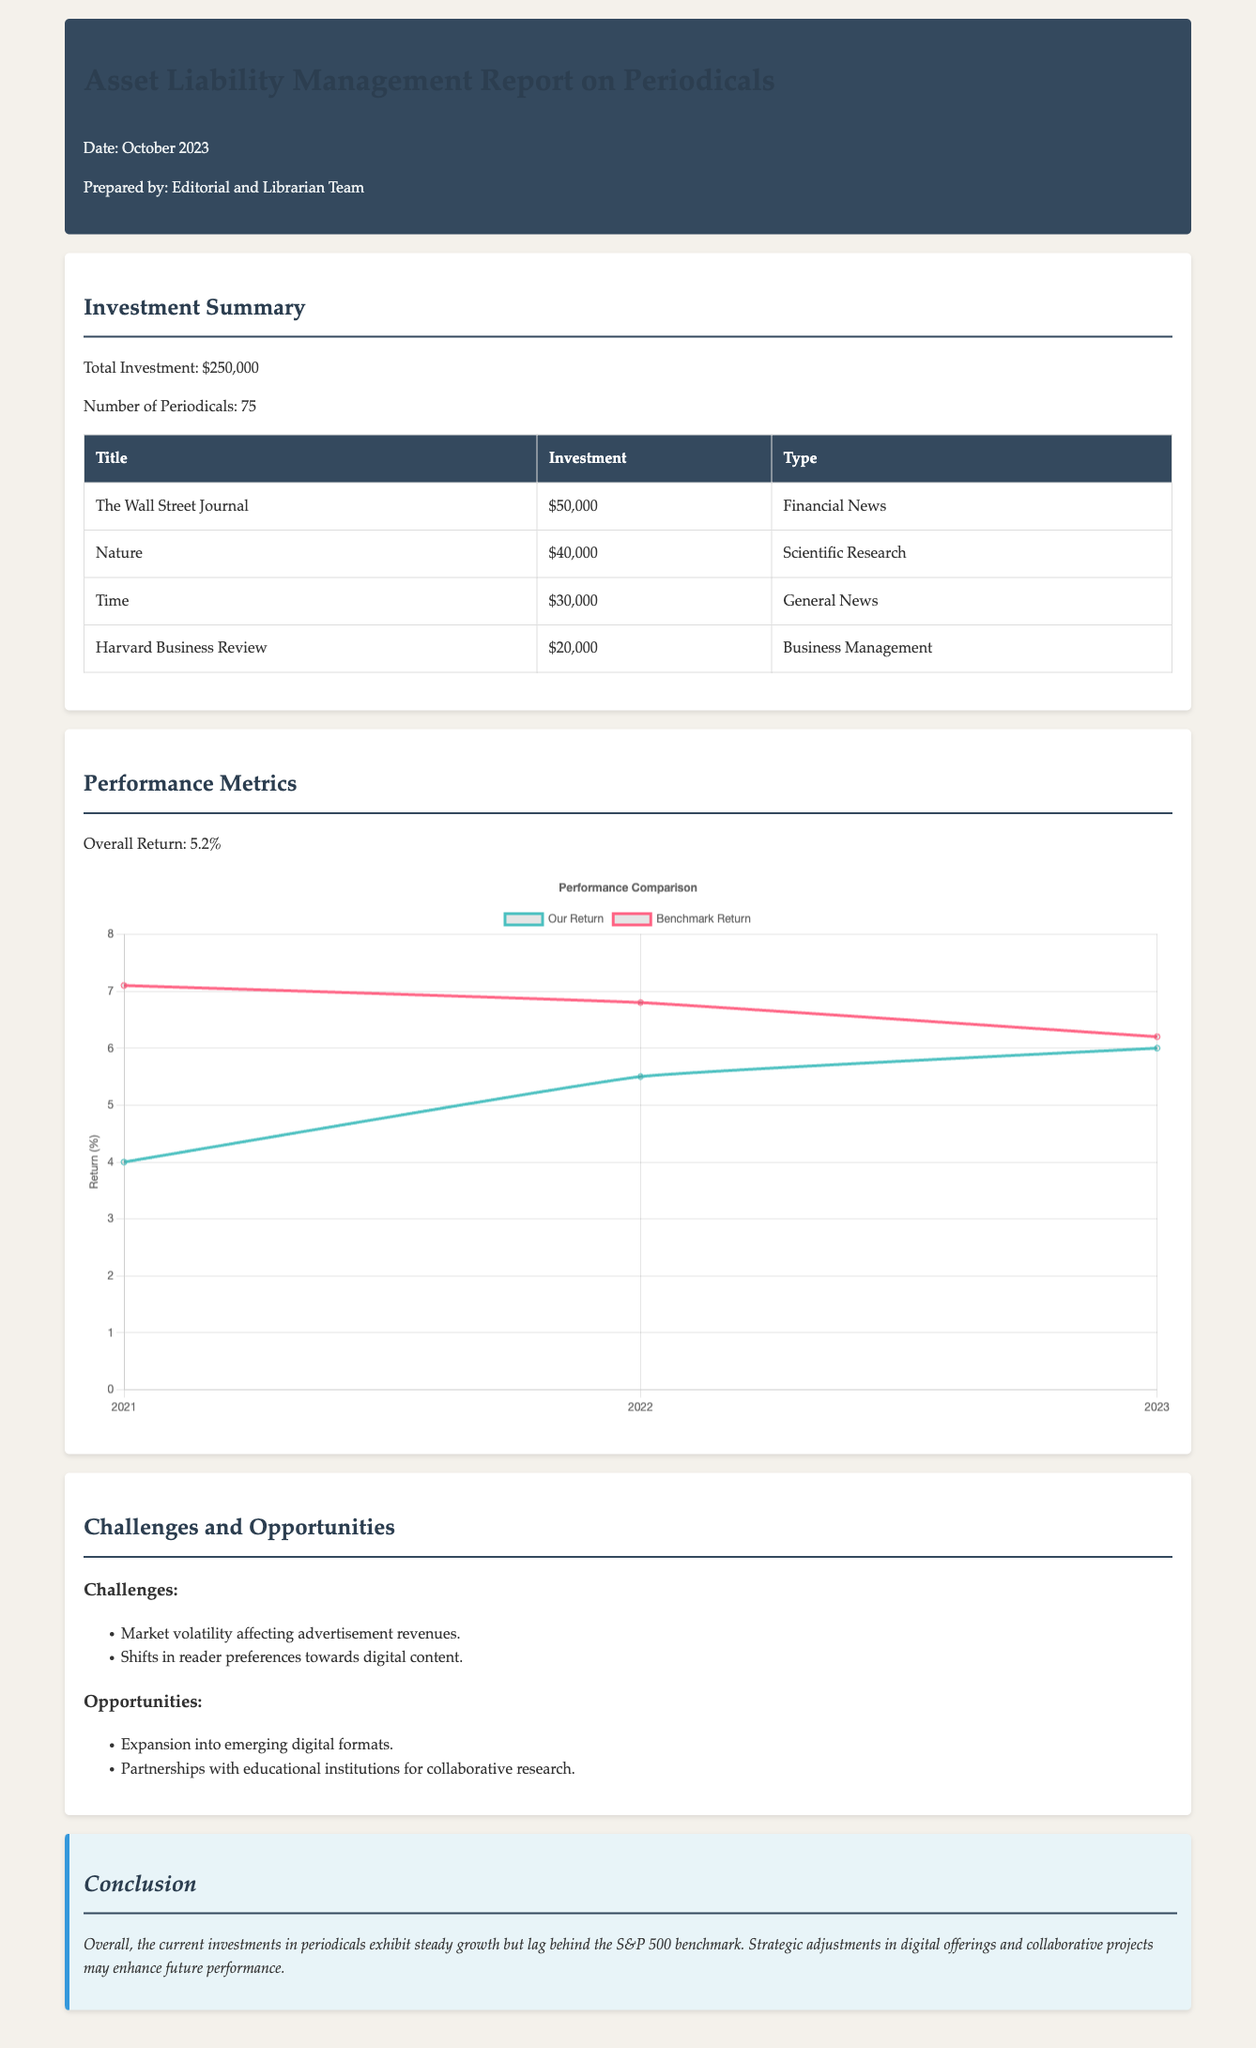what is the total investment? The total investment is explicitly stated in the investment summary section of the document.
Answer: $250,000 how many periodicals are currently invested in? The number of periodicals can be found in the investment summary section of the document.
Answer: 75 what is the name of the periodical with the highest investment? The investment table lists the titles of each periodical along with their respective investments.
Answer: The Wall Street Journal what is the overall return percentage? The overall return is detailed in the performance metrics section of the document.
Answer: 5.2% what is the return rate in 2022 for the benchmark? Both our return and benchmark return are compared in the performance chart within the document.
Answer: 6.8% what challenge is mentioned regarding market conditions? The challenges section lists specific challenges the investments are facing.
Answer: Market volatility affecting advertisement revenues what opportunity is suggested for future growth? The opportunities section outlines potential areas for growth and development regarding periodical investments.
Answer: Expansion into emerging digital formats how much is invested in the Harvard Business Review? The investment in each periodical is specified in the investment summary table.
Answer: $20,000 which year shows the highest return based on our performance? The performance chart illustrates the return rates over the years.
Answer: 2023 